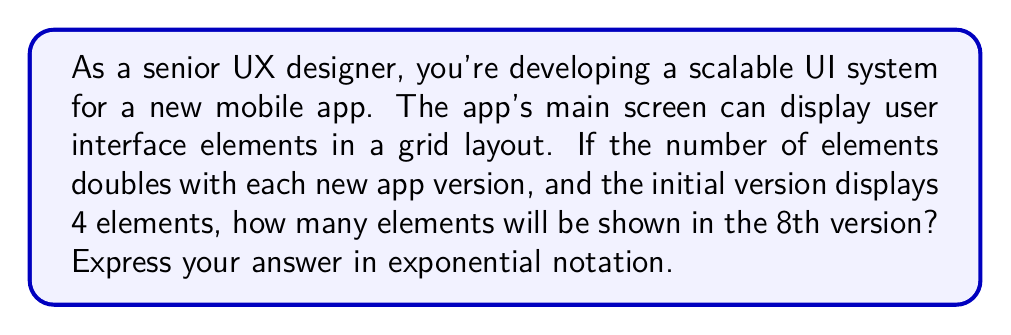Give your solution to this math problem. Let's approach this step-by-step:

1) We start with 4 elements in the initial version.

2) The number of elements doubles with each new version. This means we're multiplying by 2 each time.

3) We need to find out how many times we're doubling the initial 4 elements to reach the 8th version.

4) The pattern of growth can be expressed as:
   Version 1: $4 = 4 \times 2^0$
   Version 2: $8 = 4 \times 2^1$
   Version 3: $16 = 4 \times 2^2$
   ...
   Version 8: $4 \times 2^7$

5) The general formula is:
   Number of elements in version n = $4 \times 2^{n-1}$

6) For the 8th version, we substitute n = 8:
   Number of elements = $4 \times 2^{8-1} = 4 \times 2^7$

7) Calculate:
   $4 \times 2^7 = 4 \times 128 = 512$

8) Express in exponential notation:
   $512 = 2^9$

Therefore, in the 8th version, there will be $2^9$ elements displayed.
Answer: $2^9$ 